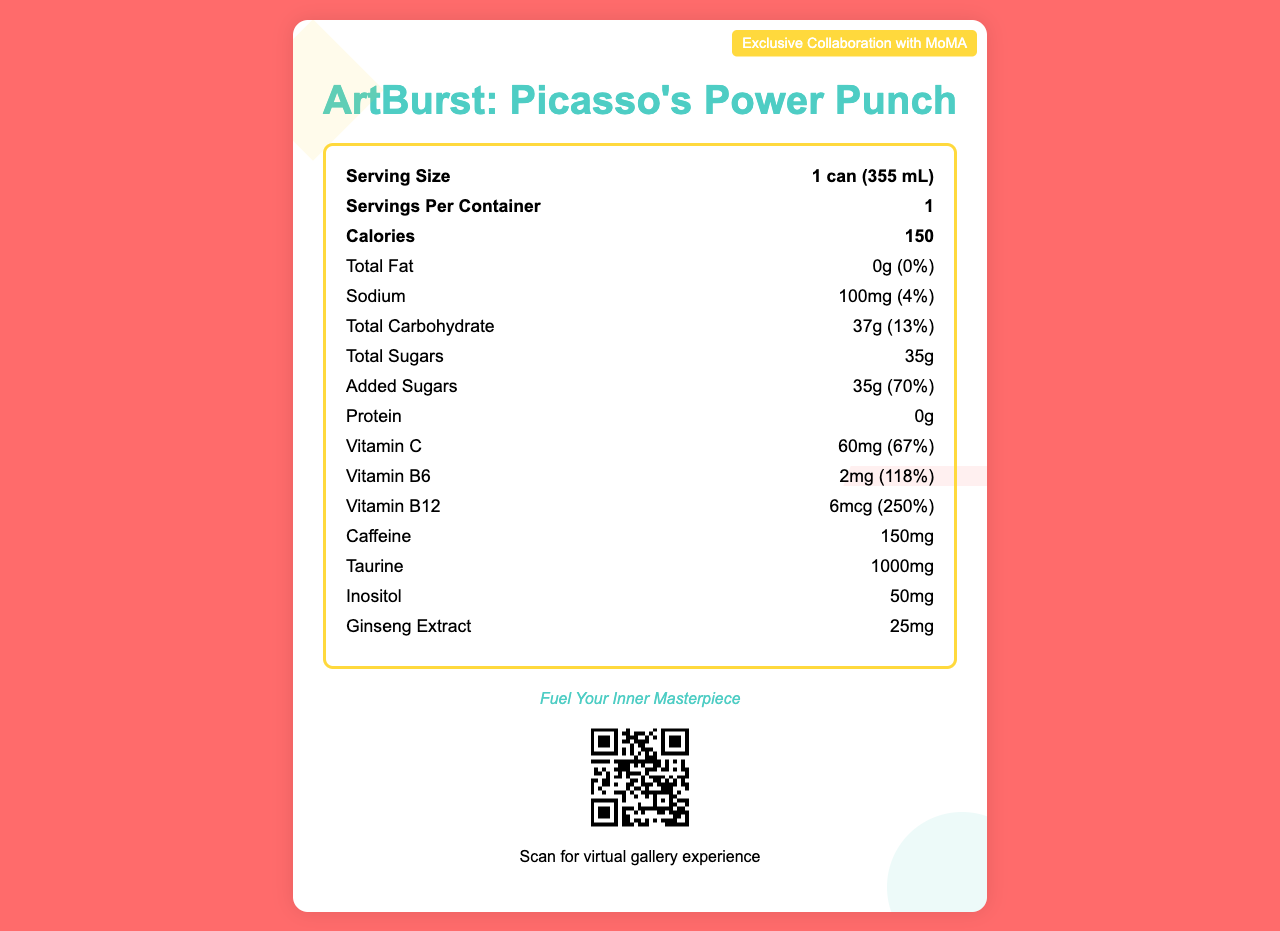what is the serving size for ArtBurst: Picasso's Power Punch? The serving size is clearly written as "1 can (355 mL)" on the nutrition facts label.
Answer: 1 can (355 mL) how many calories are in one serving of the energy drink? The label lists the calories per serving as 150.
Answer: 150 what colors are used in the label's color scheme? The document specifies the primary, secondary, and accent colors in the color scheme.
Answer: Primary: #FF6B6B, Secondary: #4ECDC4, Accent: #FFD93D what type of packaging is used for this product? The description of the packaging is given as "Recyclable aluminum can with matte finish."
Answer: Recyclable aluminum can with matte finish what vitamins are included in the energy drink? The label shows the amounts and daily values for Vitamin C, Vitamin B6, and Vitamin B12.
Answer: Vitamin C, Vitamin B6, Vitamin B12 how much added sugar does the energy drink contain? The label indicates that there are 35 grams of added sugars, making up 70% of the daily value.
Answer: 35g according to the label, who endorses the product? The label states that the product is endorsed by contemporary artist Damien Hirst.
Answer: Damien Hirst where can this energy drink be purchased? The distribution note mentions that the drink is available at select art galleries and museums worldwide.
Answer: Available at select art galleries and museums worldwide what is the primary design inspiration for this energy drink label? The artistic elements listed for the label include Cubist-inspired geometric shapes, paint splatter effect, and abstract brush strokes.
Answer: Cubist-inspired geometric shapes, Paint splatter effect, and Abstract brush strokes how much taurine is in one serving? The amount of taurine per serving is listed as 1000mg.
Answer: 1000mg what is the main slogan for the product? The label prominently features the slogan "Fuel Your Inner Masterpiece."
Answer: Fuel Your Inner Masterpiece what additional experience can be accessed using the QR code on the label? Scanning the QR code provides access to a virtual gallery experience.
Answer: Virtual gallery experience what percentage of daily value for Vitamin B12 does this drink provide? A. 67% B. 118% C. 250% The document specifies that the Vitamin B12 content accounts for 250% of the daily value.
Answer: C how is the artistic effect of the label achieved? A. Minimalist lines B. Cubist shapes and paint splatter C. Realistic portraits D. Botanical drawings The artistic elements mentioned are Cubist-inspired geometric shapes and paint splatter effect.
Answer: B does the energy drink provide protein? The protein content is listed as 0g.
Answer: No summarize the main content of the document. The summary captures the essence of the document, focusing on the key details about the product, both nutritional and artistic.
Answer: The document presents a limited edition energy drink labeled "ArtBurst: Picasso's Power Punch," with unique visual aesthetics inspired by Cubist art, and includes a range of nutritional information, amounts of specific ingredients, vitamins, and minerals. It emphasizes an artistic theme with recyclable packaging, calls to action for a virtual gallery experience via QR, and endorsements by Damien Hirst. Distribution is noted to be limited to select art galleries and museums worldwide. what is the hex color code for the primary color used in the label's design? A. #4ECDC4 B. #FFD93D C. #FF6B6B D. #FFFFFF The primary color used is #FF6B6B.
Answer: C what are the ingredients that have specific amounts listed on the label? The nutrition label lists specific amounts for caffeine, taurine, inositol, and ginseng extract.
Answer: Caffeine, Taurine, Inositol, Ginseng Extract who is the collaboration for this limited edition with? The label mentions an "Exclusive Collaboration with MoMA."
Answer: MoMA is the amount of sodium in the energy drink above 100mg? The label shows the sodium amount as 100mg.
Answer: No is there any mention of the ingredient "Guarana" on this label? The label does not mention guarana, so it cannot be determined if it is included based solely on the visual information.
Answer: Cannot be determined 